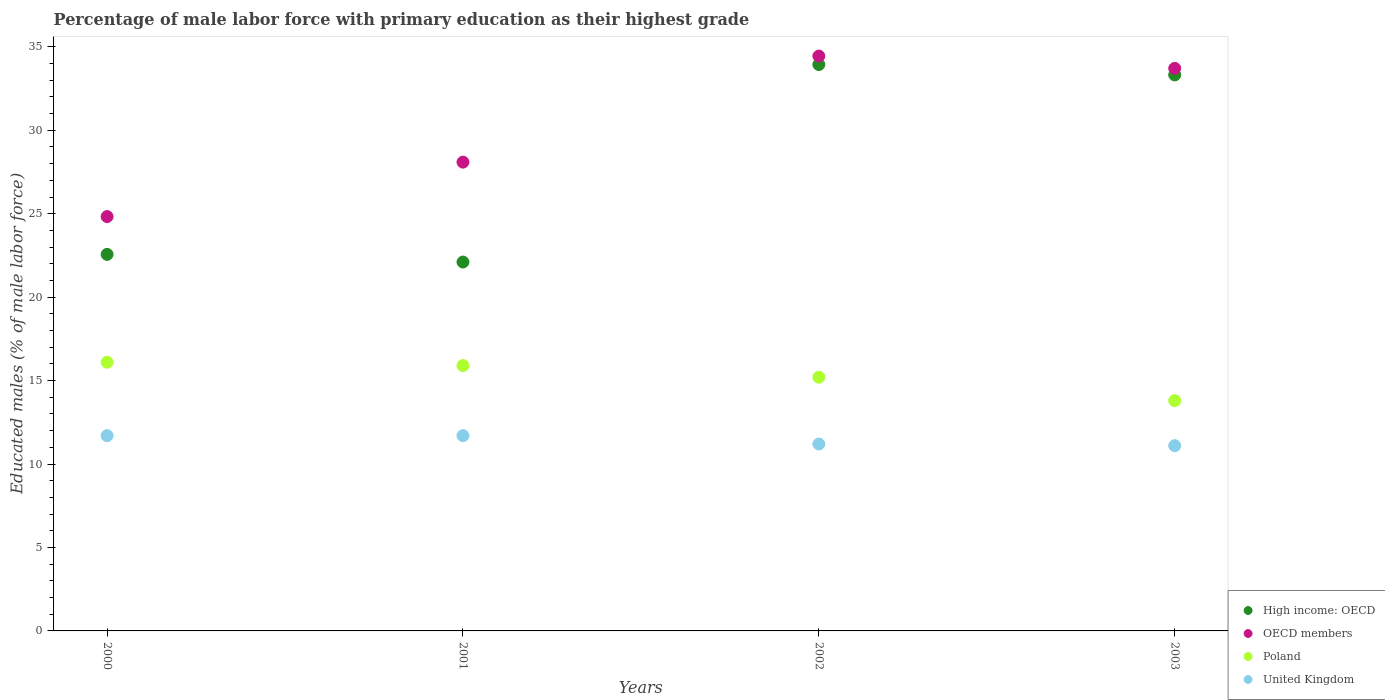How many different coloured dotlines are there?
Make the answer very short. 4. What is the percentage of male labor force with primary education in United Kingdom in 2000?
Your response must be concise. 11.7. Across all years, what is the maximum percentage of male labor force with primary education in High income: OECD?
Give a very brief answer. 33.94. Across all years, what is the minimum percentage of male labor force with primary education in Poland?
Provide a succinct answer. 13.8. In which year was the percentage of male labor force with primary education in Poland minimum?
Your answer should be very brief. 2003. What is the total percentage of male labor force with primary education in OECD members in the graph?
Offer a terse response. 121.07. What is the difference between the percentage of male labor force with primary education in OECD members in 2000 and that in 2002?
Your answer should be very brief. -9.62. What is the difference between the percentage of male labor force with primary education in OECD members in 2002 and the percentage of male labor force with primary education in United Kingdom in 2001?
Your answer should be very brief. 22.75. What is the average percentage of male labor force with primary education in OECD members per year?
Make the answer very short. 30.27. In the year 2000, what is the difference between the percentage of male labor force with primary education in Poland and percentage of male labor force with primary education in OECD members?
Provide a short and direct response. -8.73. What is the ratio of the percentage of male labor force with primary education in Poland in 2002 to that in 2003?
Offer a very short reply. 1.1. What is the difference between the highest and the lowest percentage of male labor force with primary education in United Kingdom?
Your response must be concise. 0.6. Is the sum of the percentage of male labor force with primary education in United Kingdom in 2001 and 2003 greater than the maximum percentage of male labor force with primary education in High income: OECD across all years?
Your answer should be compact. No. Is it the case that in every year, the sum of the percentage of male labor force with primary education in OECD members and percentage of male labor force with primary education in United Kingdom  is greater than the sum of percentage of male labor force with primary education in Poland and percentage of male labor force with primary education in High income: OECD?
Offer a terse response. No. Is it the case that in every year, the sum of the percentage of male labor force with primary education in High income: OECD and percentage of male labor force with primary education in OECD members  is greater than the percentage of male labor force with primary education in United Kingdom?
Give a very brief answer. Yes. Is the percentage of male labor force with primary education in High income: OECD strictly greater than the percentage of male labor force with primary education in Poland over the years?
Ensure brevity in your answer.  Yes. Does the graph contain any zero values?
Provide a short and direct response. No. Where does the legend appear in the graph?
Your answer should be compact. Bottom right. How many legend labels are there?
Make the answer very short. 4. What is the title of the graph?
Ensure brevity in your answer.  Percentage of male labor force with primary education as their highest grade. Does "Belarus" appear as one of the legend labels in the graph?
Provide a succinct answer. No. What is the label or title of the Y-axis?
Offer a very short reply. Educated males (% of male labor force). What is the Educated males (% of male labor force) of High income: OECD in 2000?
Provide a succinct answer. 22.56. What is the Educated males (% of male labor force) of OECD members in 2000?
Offer a very short reply. 24.83. What is the Educated males (% of male labor force) in Poland in 2000?
Your answer should be compact. 16.1. What is the Educated males (% of male labor force) of United Kingdom in 2000?
Keep it short and to the point. 11.7. What is the Educated males (% of male labor force) of High income: OECD in 2001?
Your answer should be compact. 22.1. What is the Educated males (% of male labor force) of OECD members in 2001?
Give a very brief answer. 28.09. What is the Educated males (% of male labor force) in Poland in 2001?
Give a very brief answer. 15.9. What is the Educated males (% of male labor force) of United Kingdom in 2001?
Your answer should be very brief. 11.7. What is the Educated males (% of male labor force) in High income: OECD in 2002?
Provide a short and direct response. 33.94. What is the Educated males (% of male labor force) of OECD members in 2002?
Keep it short and to the point. 34.45. What is the Educated males (% of male labor force) in Poland in 2002?
Offer a terse response. 15.2. What is the Educated males (% of male labor force) of United Kingdom in 2002?
Your response must be concise. 11.2. What is the Educated males (% of male labor force) of High income: OECD in 2003?
Ensure brevity in your answer.  33.31. What is the Educated males (% of male labor force) of OECD members in 2003?
Offer a very short reply. 33.71. What is the Educated males (% of male labor force) of Poland in 2003?
Your answer should be compact. 13.8. What is the Educated males (% of male labor force) in United Kingdom in 2003?
Keep it short and to the point. 11.1. Across all years, what is the maximum Educated males (% of male labor force) in High income: OECD?
Ensure brevity in your answer.  33.94. Across all years, what is the maximum Educated males (% of male labor force) of OECD members?
Your response must be concise. 34.45. Across all years, what is the maximum Educated males (% of male labor force) in Poland?
Your answer should be compact. 16.1. Across all years, what is the maximum Educated males (% of male labor force) in United Kingdom?
Give a very brief answer. 11.7. Across all years, what is the minimum Educated males (% of male labor force) of High income: OECD?
Offer a terse response. 22.1. Across all years, what is the minimum Educated males (% of male labor force) in OECD members?
Offer a very short reply. 24.83. Across all years, what is the minimum Educated males (% of male labor force) in Poland?
Ensure brevity in your answer.  13.8. Across all years, what is the minimum Educated males (% of male labor force) in United Kingdom?
Make the answer very short. 11.1. What is the total Educated males (% of male labor force) of High income: OECD in the graph?
Offer a very short reply. 111.92. What is the total Educated males (% of male labor force) in OECD members in the graph?
Your answer should be very brief. 121.07. What is the total Educated males (% of male labor force) of Poland in the graph?
Your answer should be very brief. 61. What is the total Educated males (% of male labor force) of United Kingdom in the graph?
Your answer should be very brief. 45.7. What is the difference between the Educated males (% of male labor force) in High income: OECD in 2000 and that in 2001?
Provide a short and direct response. 0.46. What is the difference between the Educated males (% of male labor force) in OECD members in 2000 and that in 2001?
Make the answer very short. -3.26. What is the difference between the Educated males (% of male labor force) in United Kingdom in 2000 and that in 2001?
Your answer should be compact. 0. What is the difference between the Educated males (% of male labor force) in High income: OECD in 2000 and that in 2002?
Provide a short and direct response. -11.37. What is the difference between the Educated males (% of male labor force) in OECD members in 2000 and that in 2002?
Give a very brief answer. -9.62. What is the difference between the Educated males (% of male labor force) of High income: OECD in 2000 and that in 2003?
Offer a terse response. -10.75. What is the difference between the Educated males (% of male labor force) in OECD members in 2000 and that in 2003?
Ensure brevity in your answer.  -8.88. What is the difference between the Educated males (% of male labor force) of United Kingdom in 2000 and that in 2003?
Offer a very short reply. 0.6. What is the difference between the Educated males (% of male labor force) of High income: OECD in 2001 and that in 2002?
Provide a succinct answer. -11.83. What is the difference between the Educated males (% of male labor force) in OECD members in 2001 and that in 2002?
Offer a terse response. -6.36. What is the difference between the Educated males (% of male labor force) of United Kingdom in 2001 and that in 2002?
Your response must be concise. 0.5. What is the difference between the Educated males (% of male labor force) in High income: OECD in 2001 and that in 2003?
Provide a short and direct response. -11.21. What is the difference between the Educated males (% of male labor force) of OECD members in 2001 and that in 2003?
Offer a very short reply. -5.62. What is the difference between the Educated males (% of male labor force) in Poland in 2001 and that in 2003?
Offer a terse response. 2.1. What is the difference between the Educated males (% of male labor force) in High income: OECD in 2002 and that in 2003?
Make the answer very short. 0.62. What is the difference between the Educated males (% of male labor force) of OECD members in 2002 and that in 2003?
Give a very brief answer. 0.74. What is the difference between the Educated males (% of male labor force) of Poland in 2002 and that in 2003?
Your response must be concise. 1.4. What is the difference between the Educated males (% of male labor force) of High income: OECD in 2000 and the Educated males (% of male labor force) of OECD members in 2001?
Keep it short and to the point. -5.53. What is the difference between the Educated males (% of male labor force) in High income: OECD in 2000 and the Educated males (% of male labor force) in Poland in 2001?
Offer a terse response. 6.66. What is the difference between the Educated males (% of male labor force) in High income: OECD in 2000 and the Educated males (% of male labor force) in United Kingdom in 2001?
Provide a short and direct response. 10.86. What is the difference between the Educated males (% of male labor force) in OECD members in 2000 and the Educated males (% of male labor force) in Poland in 2001?
Ensure brevity in your answer.  8.93. What is the difference between the Educated males (% of male labor force) of OECD members in 2000 and the Educated males (% of male labor force) of United Kingdom in 2001?
Ensure brevity in your answer.  13.13. What is the difference between the Educated males (% of male labor force) of Poland in 2000 and the Educated males (% of male labor force) of United Kingdom in 2001?
Your answer should be compact. 4.4. What is the difference between the Educated males (% of male labor force) of High income: OECD in 2000 and the Educated males (% of male labor force) of OECD members in 2002?
Keep it short and to the point. -11.88. What is the difference between the Educated males (% of male labor force) of High income: OECD in 2000 and the Educated males (% of male labor force) of Poland in 2002?
Keep it short and to the point. 7.36. What is the difference between the Educated males (% of male labor force) of High income: OECD in 2000 and the Educated males (% of male labor force) of United Kingdom in 2002?
Make the answer very short. 11.36. What is the difference between the Educated males (% of male labor force) in OECD members in 2000 and the Educated males (% of male labor force) in Poland in 2002?
Make the answer very short. 9.63. What is the difference between the Educated males (% of male labor force) in OECD members in 2000 and the Educated males (% of male labor force) in United Kingdom in 2002?
Give a very brief answer. 13.63. What is the difference between the Educated males (% of male labor force) of Poland in 2000 and the Educated males (% of male labor force) of United Kingdom in 2002?
Offer a very short reply. 4.9. What is the difference between the Educated males (% of male labor force) of High income: OECD in 2000 and the Educated males (% of male labor force) of OECD members in 2003?
Provide a succinct answer. -11.15. What is the difference between the Educated males (% of male labor force) in High income: OECD in 2000 and the Educated males (% of male labor force) in Poland in 2003?
Give a very brief answer. 8.76. What is the difference between the Educated males (% of male labor force) in High income: OECD in 2000 and the Educated males (% of male labor force) in United Kingdom in 2003?
Keep it short and to the point. 11.46. What is the difference between the Educated males (% of male labor force) of OECD members in 2000 and the Educated males (% of male labor force) of Poland in 2003?
Provide a succinct answer. 11.03. What is the difference between the Educated males (% of male labor force) in OECD members in 2000 and the Educated males (% of male labor force) in United Kingdom in 2003?
Keep it short and to the point. 13.73. What is the difference between the Educated males (% of male labor force) of Poland in 2000 and the Educated males (% of male labor force) of United Kingdom in 2003?
Make the answer very short. 5. What is the difference between the Educated males (% of male labor force) in High income: OECD in 2001 and the Educated males (% of male labor force) in OECD members in 2002?
Make the answer very short. -12.34. What is the difference between the Educated males (% of male labor force) of High income: OECD in 2001 and the Educated males (% of male labor force) of Poland in 2002?
Your answer should be compact. 6.9. What is the difference between the Educated males (% of male labor force) in High income: OECD in 2001 and the Educated males (% of male labor force) in United Kingdom in 2002?
Offer a very short reply. 10.9. What is the difference between the Educated males (% of male labor force) of OECD members in 2001 and the Educated males (% of male labor force) of Poland in 2002?
Ensure brevity in your answer.  12.89. What is the difference between the Educated males (% of male labor force) in OECD members in 2001 and the Educated males (% of male labor force) in United Kingdom in 2002?
Ensure brevity in your answer.  16.89. What is the difference between the Educated males (% of male labor force) in Poland in 2001 and the Educated males (% of male labor force) in United Kingdom in 2002?
Your answer should be very brief. 4.7. What is the difference between the Educated males (% of male labor force) of High income: OECD in 2001 and the Educated males (% of male labor force) of OECD members in 2003?
Offer a very short reply. -11.6. What is the difference between the Educated males (% of male labor force) in High income: OECD in 2001 and the Educated males (% of male labor force) in Poland in 2003?
Ensure brevity in your answer.  8.3. What is the difference between the Educated males (% of male labor force) in High income: OECD in 2001 and the Educated males (% of male labor force) in United Kingdom in 2003?
Offer a very short reply. 11. What is the difference between the Educated males (% of male labor force) of OECD members in 2001 and the Educated males (% of male labor force) of Poland in 2003?
Your response must be concise. 14.29. What is the difference between the Educated males (% of male labor force) of OECD members in 2001 and the Educated males (% of male labor force) of United Kingdom in 2003?
Your answer should be compact. 16.99. What is the difference between the Educated males (% of male labor force) of High income: OECD in 2002 and the Educated males (% of male labor force) of OECD members in 2003?
Keep it short and to the point. 0.23. What is the difference between the Educated males (% of male labor force) of High income: OECD in 2002 and the Educated males (% of male labor force) of Poland in 2003?
Keep it short and to the point. 20.14. What is the difference between the Educated males (% of male labor force) in High income: OECD in 2002 and the Educated males (% of male labor force) in United Kingdom in 2003?
Your response must be concise. 22.84. What is the difference between the Educated males (% of male labor force) of OECD members in 2002 and the Educated males (% of male labor force) of Poland in 2003?
Provide a succinct answer. 20.65. What is the difference between the Educated males (% of male labor force) in OECD members in 2002 and the Educated males (% of male labor force) in United Kingdom in 2003?
Provide a short and direct response. 23.35. What is the average Educated males (% of male labor force) in High income: OECD per year?
Provide a short and direct response. 27.98. What is the average Educated males (% of male labor force) of OECD members per year?
Your response must be concise. 30.27. What is the average Educated males (% of male labor force) of Poland per year?
Your response must be concise. 15.25. What is the average Educated males (% of male labor force) of United Kingdom per year?
Provide a succinct answer. 11.43. In the year 2000, what is the difference between the Educated males (% of male labor force) in High income: OECD and Educated males (% of male labor force) in OECD members?
Make the answer very short. -2.26. In the year 2000, what is the difference between the Educated males (% of male labor force) of High income: OECD and Educated males (% of male labor force) of Poland?
Your answer should be very brief. 6.46. In the year 2000, what is the difference between the Educated males (% of male labor force) of High income: OECD and Educated males (% of male labor force) of United Kingdom?
Provide a succinct answer. 10.86. In the year 2000, what is the difference between the Educated males (% of male labor force) of OECD members and Educated males (% of male labor force) of Poland?
Your answer should be compact. 8.73. In the year 2000, what is the difference between the Educated males (% of male labor force) of OECD members and Educated males (% of male labor force) of United Kingdom?
Your answer should be compact. 13.13. In the year 2001, what is the difference between the Educated males (% of male labor force) of High income: OECD and Educated males (% of male labor force) of OECD members?
Provide a succinct answer. -5.99. In the year 2001, what is the difference between the Educated males (% of male labor force) of High income: OECD and Educated males (% of male labor force) of Poland?
Make the answer very short. 6.2. In the year 2001, what is the difference between the Educated males (% of male labor force) in High income: OECD and Educated males (% of male labor force) in United Kingdom?
Provide a short and direct response. 10.4. In the year 2001, what is the difference between the Educated males (% of male labor force) in OECD members and Educated males (% of male labor force) in Poland?
Give a very brief answer. 12.19. In the year 2001, what is the difference between the Educated males (% of male labor force) of OECD members and Educated males (% of male labor force) of United Kingdom?
Keep it short and to the point. 16.39. In the year 2002, what is the difference between the Educated males (% of male labor force) of High income: OECD and Educated males (% of male labor force) of OECD members?
Your answer should be compact. -0.51. In the year 2002, what is the difference between the Educated males (% of male labor force) of High income: OECD and Educated males (% of male labor force) of Poland?
Make the answer very short. 18.74. In the year 2002, what is the difference between the Educated males (% of male labor force) of High income: OECD and Educated males (% of male labor force) of United Kingdom?
Keep it short and to the point. 22.74. In the year 2002, what is the difference between the Educated males (% of male labor force) of OECD members and Educated males (% of male labor force) of Poland?
Offer a very short reply. 19.25. In the year 2002, what is the difference between the Educated males (% of male labor force) of OECD members and Educated males (% of male labor force) of United Kingdom?
Provide a short and direct response. 23.25. In the year 2002, what is the difference between the Educated males (% of male labor force) of Poland and Educated males (% of male labor force) of United Kingdom?
Keep it short and to the point. 4. In the year 2003, what is the difference between the Educated males (% of male labor force) of High income: OECD and Educated males (% of male labor force) of OECD members?
Keep it short and to the point. -0.39. In the year 2003, what is the difference between the Educated males (% of male labor force) in High income: OECD and Educated males (% of male labor force) in Poland?
Offer a terse response. 19.51. In the year 2003, what is the difference between the Educated males (% of male labor force) of High income: OECD and Educated males (% of male labor force) of United Kingdom?
Offer a terse response. 22.21. In the year 2003, what is the difference between the Educated males (% of male labor force) in OECD members and Educated males (% of male labor force) in Poland?
Offer a terse response. 19.91. In the year 2003, what is the difference between the Educated males (% of male labor force) in OECD members and Educated males (% of male labor force) in United Kingdom?
Offer a very short reply. 22.61. What is the ratio of the Educated males (% of male labor force) of High income: OECD in 2000 to that in 2001?
Offer a very short reply. 1.02. What is the ratio of the Educated males (% of male labor force) in OECD members in 2000 to that in 2001?
Give a very brief answer. 0.88. What is the ratio of the Educated males (% of male labor force) in Poland in 2000 to that in 2001?
Offer a very short reply. 1.01. What is the ratio of the Educated males (% of male labor force) in United Kingdom in 2000 to that in 2001?
Give a very brief answer. 1. What is the ratio of the Educated males (% of male labor force) in High income: OECD in 2000 to that in 2002?
Provide a succinct answer. 0.66. What is the ratio of the Educated males (% of male labor force) in OECD members in 2000 to that in 2002?
Your response must be concise. 0.72. What is the ratio of the Educated males (% of male labor force) in Poland in 2000 to that in 2002?
Ensure brevity in your answer.  1.06. What is the ratio of the Educated males (% of male labor force) of United Kingdom in 2000 to that in 2002?
Your answer should be compact. 1.04. What is the ratio of the Educated males (% of male labor force) of High income: OECD in 2000 to that in 2003?
Offer a very short reply. 0.68. What is the ratio of the Educated males (% of male labor force) of OECD members in 2000 to that in 2003?
Your answer should be very brief. 0.74. What is the ratio of the Educated males (% of male labor force) of Poland in 2000 to that in 2003?
Ensure brevity in your answer.  1.17. What is the ratio of the Educated males (% of male labor force) of United Kingdom in 2000 to that in 2003?
Give a very brief answer. 1.05. What is the ratio of the Educated males (% of male labor force) in High income: OECD in 2001 to that in 2002?
Offer a terse response. 0.65. What is the ratio of the Educated males (% of male labor force) in OECD members in 2001 to that in 2002?
Ensure brevity in your answer.  0.82. What is the ratio of the Educated males (% of male labor force) of Poland in 2001 to that in 2002?
Offer a terse response. 1.05. What is the ratio of the Educated males (% of male labor force) in United Kingdom in 2001 to that in 2002?
Offer a terse response. 1.04. What is the ratio of the Educated males (% of male labor force) of High income: OECD in 2001 to that in 2003?
Make the answer very short. 0.66. What is the ratio of the Educated males (% of male labor force) in OECD members in 2001 to that in 2003?
Give a very brief answer. 0.83. What is the ratio of the Educated males (% of male labor force) of Poland in 2001 to that in 2003?
Make the answer very short. 1.15. What is the ratio of the Educated males (% of male labor force) of United Kingdom in 2001 to that in 2003?
Keep it short and to the point. 1.05. What is the ratio of the Educated males (% of male labor force) in High income: OECD in 2002 to that in 2003?
Your answer should be compact. 1.02. What is the ratio of the Educated males (% of male labor force) in OECD members in 2002 to that in 2003?
Offer a terse response. 1.02. What is the ratio of the Educated males (% of male labor force) of Poland in 2002 to that in 2003?
Provide a short and direct response. 1.1. What is the ratio of the Educated males (% of male labor force) in United Kingdom in 2002 to that in 2003?
Provide a short and direct response. 1.01. What is the difference between the highest and the second highest Educated males (% of male labor force) of High income: OECD?
Your answer should be very brief. 0.62. What is the difference between the highest and the second highest Educated males (% of male labor force) of OECD members?
Keep it short and to the point. 0.74. What is the difference between the highest and the lowest Educated males (% of male labor force) in High income: OECD?
Make the answer very short. 11.83. What is the difference between the highest and the lowest Educated males (% of male labor force) in OECD members?
Your answer should be very brief. 9.62. 